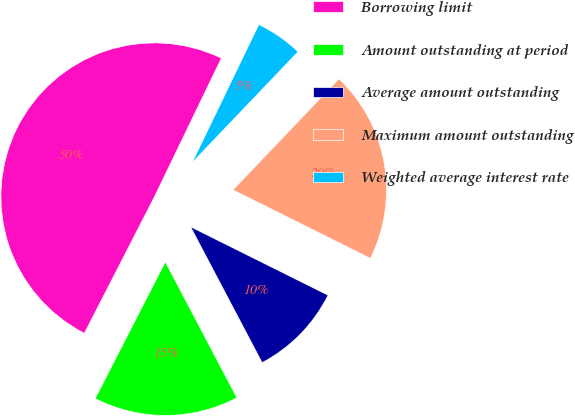Convert chart. <chart><loc_0><loc_0><loc_500><loc_500><pie_chart><fcel>Borrowing limit<fcel>Amount outstanding at period<fcel>Average amount outstanding<fcel>Maximum amount outstanding<fcel>Weighted average interest rate<nl><fcel>49.61%<fcel>15.26%<fcel>9.93%<fcel>20.22%<fcel>4.97%<nl></chart> 